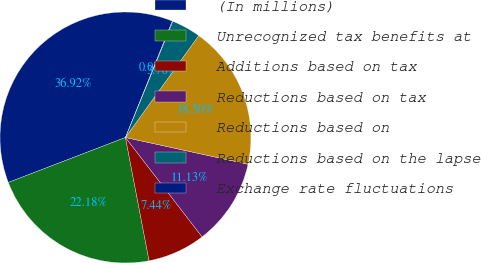Convert chart to OTSL. <chart><loc_0><loc_0><loc_500><loc_500><pie_chart><fcel>(In millions)<fcel>Unrecognized tax benefits at<fcel>Additions based on tax<fcel>Reductions based on tax<fcel>Reductions based on<fcel>Reductions based on the lapse<fcel>Exchange rate fluctuations<nl><fcel>36.92%<fcel>22.18%<fcel>7.44%<fcel>11.13%<fcel>18.5%<fcel>3.76%<fcel>0.07%<nl></chart> 